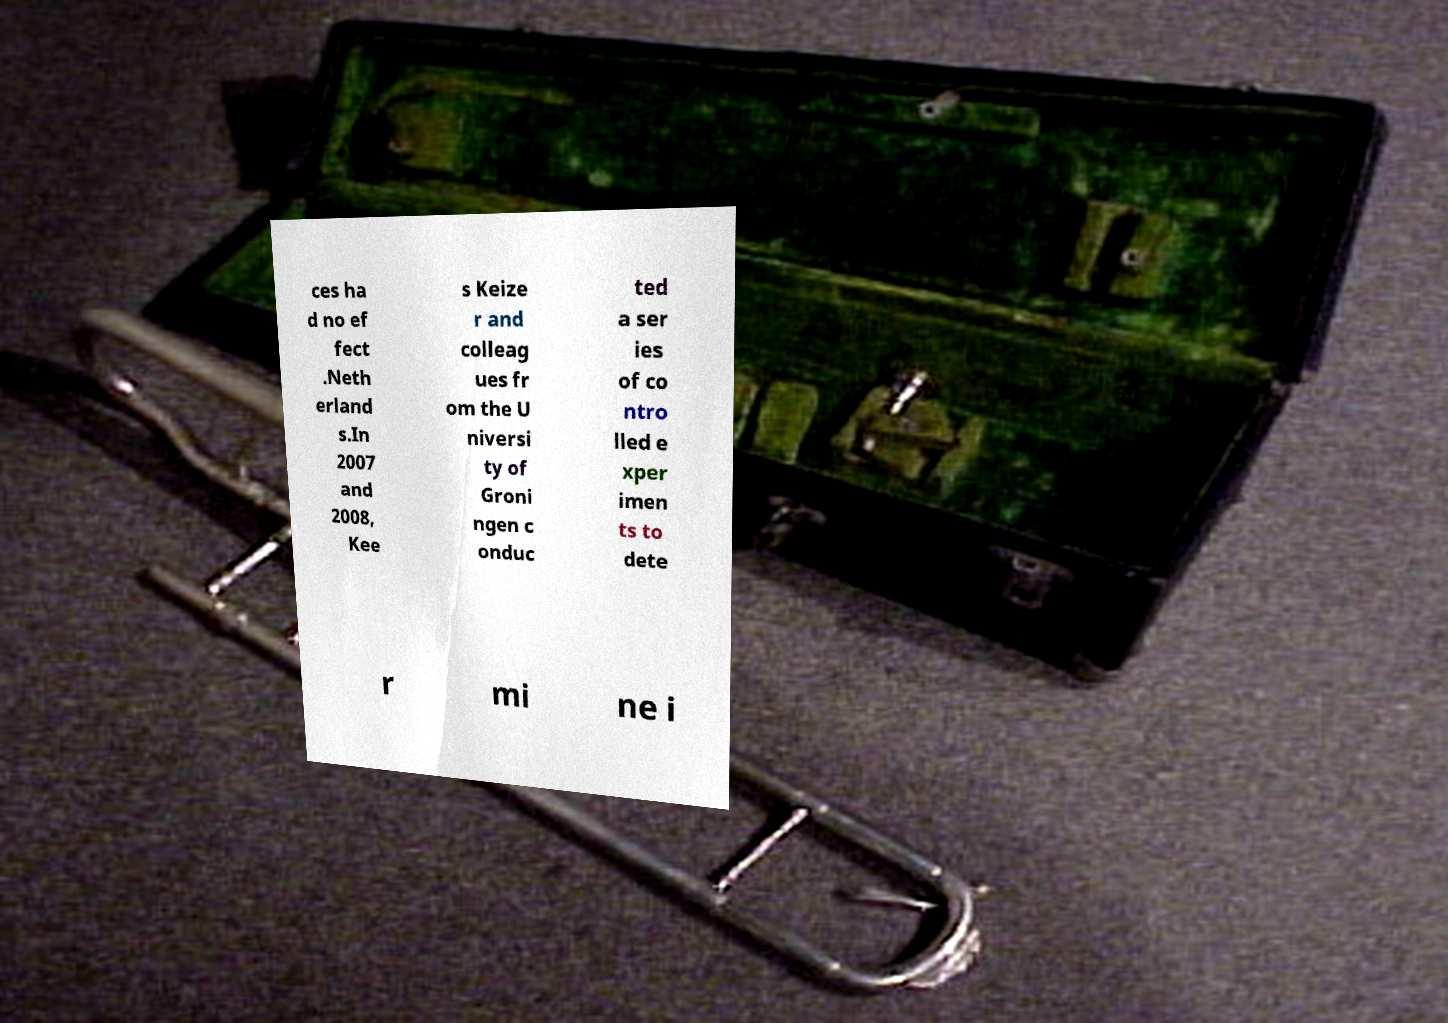Please read and relay the text visible in this image. What does it say? ces ha d no ef fect .Neth erland s.In 2007 and 2008, Kee s Keize r and colleag ues fr om the U niversi ty of Groni ngen c onduc ted a ser ies of co ntro lled e xper imen ts to dete r mi ne i 